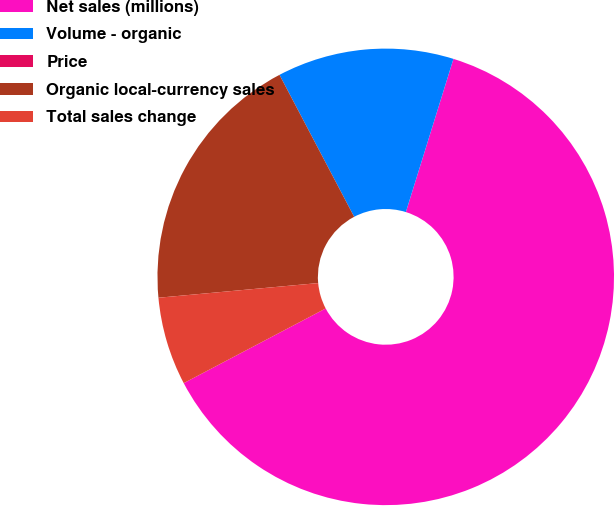Convert chart to OTSL. <chart><loc_0><loc_0><loc_500><loc_500><pie_chart><fcel>Net sales (millions)<fcel>Volume - organic<fcel>Price<fcel>Organic local-currency sales<fcel>Total sales change<nl><fcel>62.5%<fcel>12.5%<fcel>0.0%<fcel>18.75%<fcel>6.25%<nl></chart> 